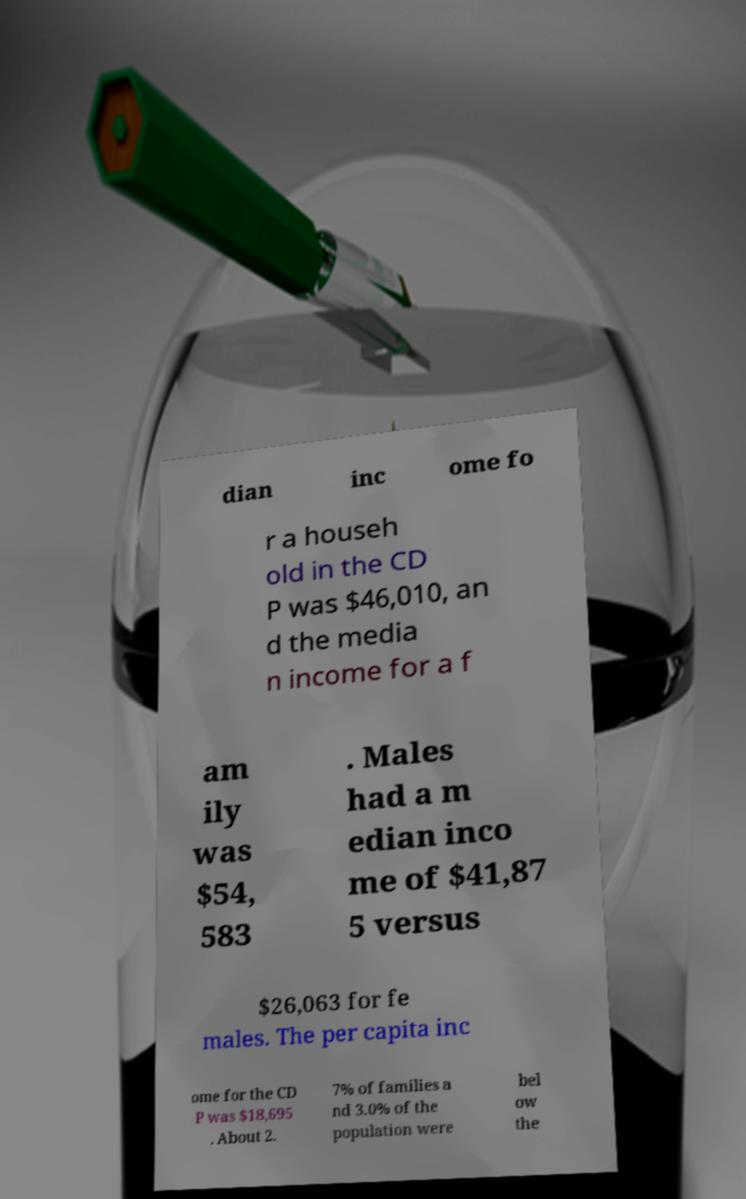Can you accurately transcribe the text from the provided image for me? dian inc ome fo r a househ old in the CD P was $46,010, an d the media n income for a f am ily was $54, 583 . Males had a m edian inco me of $41,87 5 versus $26,063 for fe males. The per capita inc ome for the CD P was $18,695 . About 2. 7% of families a nd 3.0% of the population were bel ow the 